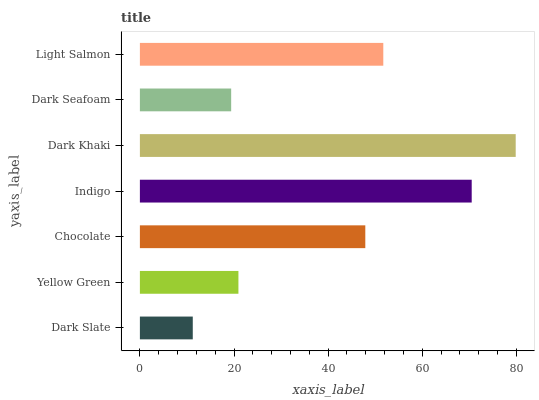Is Dark Slate the minimum?
Answer yes or no. Yes. Is Dark Khaki the maximum?
Answer yes or no. Yes. Is Yellow Green the minimum?
Answer yes or no. No. Is Yellow Green the maximum?
Answer yes or no. No. Is Yellow Green greater than Dark Slate?
Answer yes or no. Yes. Is Dark Slate less than Yellow Green?
Answer yes or no. Yes. Is Dark Slate greater than Yellow Green?
Answer yes or no. No. Is Yellow Green less than Dark Slate?
Answer yes or no. No. Is Chocolate the high median?
Answer yes or no. Yes. Is Chocolate the low median?
Answer yes or no. Yes. Is Light Salmon the high median?
Answer yes or no. No. Is Dark Seafoam the low median?
Answer yes or no. No. 